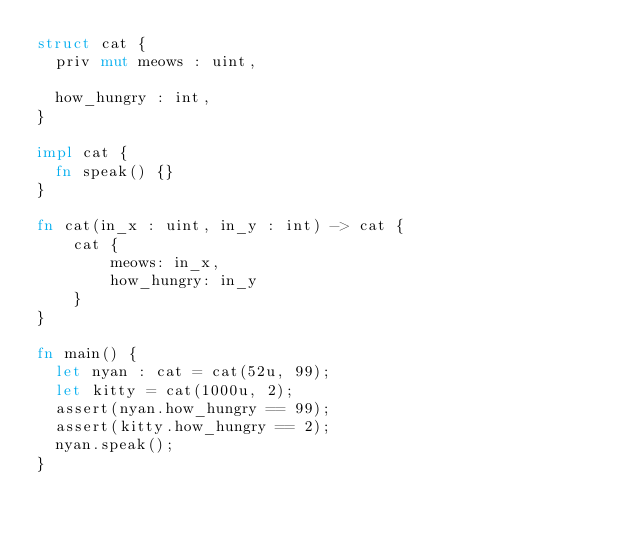Convert code to text. <code><loc_0><loc_0><loc_500><loc_500><_Rust_>struct cat {
  priv mut meows : uint,

  how_hungry : int,
}

impl cat {
  fn speak() {}
}

fn cat(in_x : uint, in_y : int) -> cat {
    cat {
        meows: in_x,
        how_hungry: in_y
    }
}

fn main() {
  let nyan : cat = cat(52u, 99);
  let kitty = cat(1000u, 2);
  assert(nyan.how_hungry == 99);
  assert(kitty.how_hungry == 2);
  nyan.speak();
}
</code> 